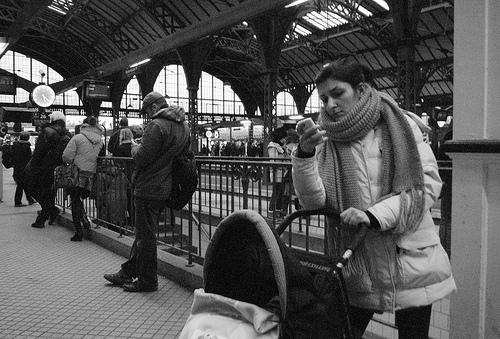Explain the scene where the man is leaning. The man is leaning against a metal railing behind the woman with a stroller. Identify the object located above the man in the image. A glowing white clock is located above the man. Mention one accessory the man is carrying with him. The man is carrying a black backpack with him. Please describe the type of clothing the woman is wearing. The woman is dressed for cold weather, wearing a white puffed jacket, a scarf, and winter boots. What is unique about the woman's hair in this picture? The woman has dark hair in a ponytail. Can you tell me what the woman is holding and what she is doing with it? The woman is holding a cell phone in her hand and looking at it. What type of architectural element is featured in the image? There are stairs leading underground with a metal railing. Describe the posture of the woman with the baby stroller. The woman is leaning on the baby stroller. Count the number of people in the image and what they are doing. There are four people: a woman looking at her phone leaning on a stroller, a man with a backpack and a hat leaning against a rail, a woman in a dress with winter boots, and another woman holding a large purse. Analyze the image's sentiment based on the physical cues. The people in the image appear to be calmly going about their day, with the woman engrossed in her phone and others waiting or leaning against rails. There's no strong emotional sentiment visible. State the action that the woman is performing with her phone. The woman is looking at her phone. What is the color of the woman's jacket? White In the image, what type of flooring is visible? Tiled floor Describe the appearance and position of the man in this image. The man is wearing a hat, a jacket with a hoodie, and a black backpack, and he's leaning against a rail. What additional item is the woman in the dress holding besides her purse? A cell phone What are some of the interactions happening between the main woman and her belongings? The woman is holding onto a stroller, looking at her phone, and wearing a winter coat and scarf. What is unique about the clock's appearance? It's a glowing white clock. What kind of clothing does the woman seem to be wearing for the weather? Cold weather clothing Is there a man playing a guitar near the window on the building? There's a mention of a window on a building, but no reference to anyone playing a guitar in the image. What is the woman leaning on? B. A stroller Outline the clothing worn by the woman in the image. The woman is wearing a white coat, a scarf, a dress, and winter boots. Based on the hairstyle worn by the woman, how would you describe her hair? A dark ponytail. Does the woman with the green jacket have a dog? There's no mention of a dog in the image, nor any reference to the color green. What part of the man's outfit includes a hat? He is wearing a hat on his head. Is the clock on the wall showing the time as 12:30? There is a mention of a clock, but the given time in the image is 5:30, not 12:30. Does the woman holding a phone have blue hair? There's mention of a woman holding a phone, but no reference to her having blue hair. What time does the clock indicate in this image? 5:30 Where is the clock in relation to the man? The clock is above the man. What position is the main woman in, as she interacts with the stroller? She is leaning on the stroller. Discuss the connection between the man and the backpack. The man is holding a black backpack. Is there a bicycle next to the stairs leading underground? There is a mention of stairs leading underground, but no mention of a bicycle in the image. What can you conclude about the woman's outerwear from the image? She is wearing a white, puffed coat and a scarf. Is the man with the red hat carrying an umbrella? There's no mention of a red hat or an umbrella in the image. What type of railing is behind the woman with the stroller? Metal railing 